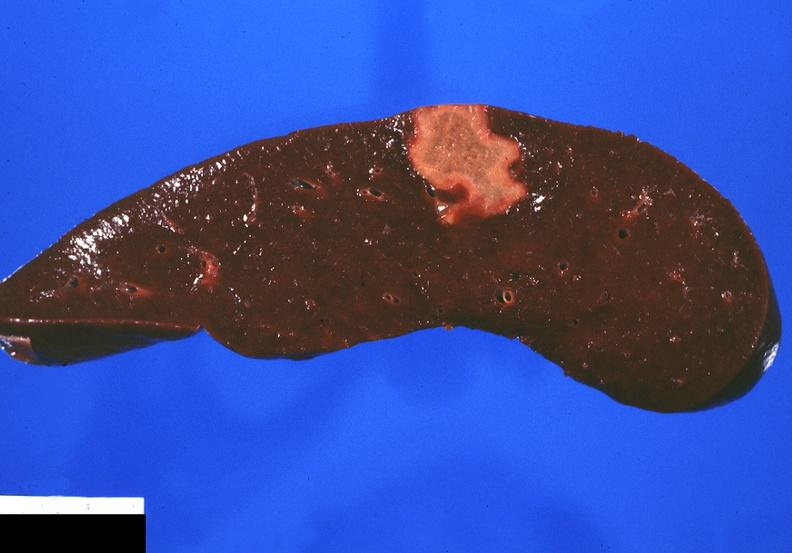s hematologic present?
Answer the question using a single word or phrase. Yes 